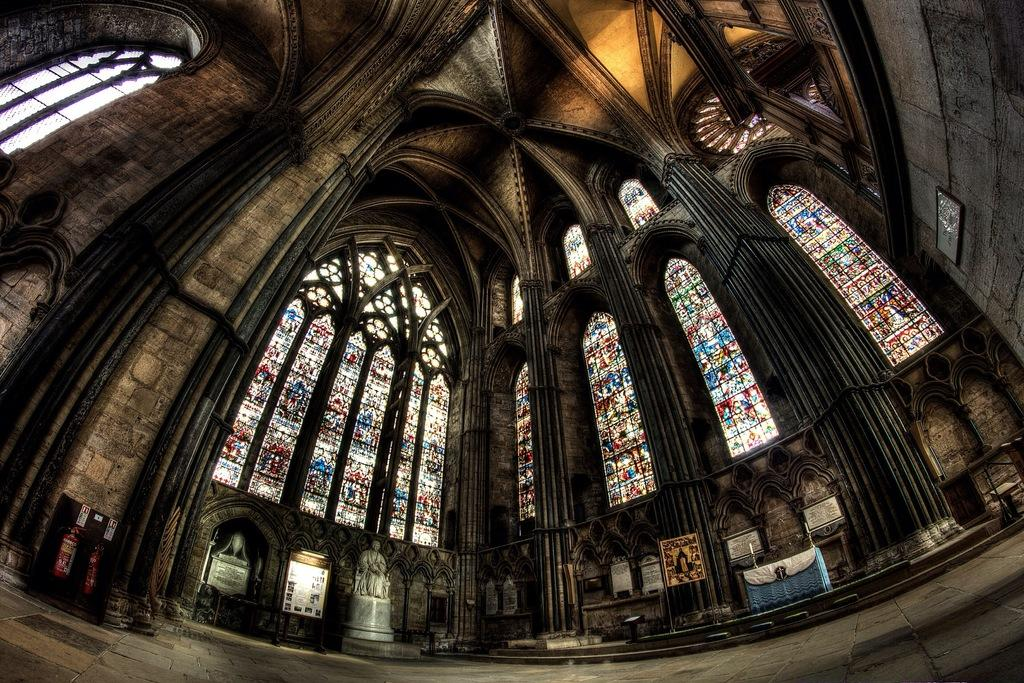What type of building is shown in the image? The image is an inside view of a church building. What feature can be seen in the church that allows natural light to enter? There are big glass windows in the church. What type of decorative elements are present in the church? There are statues in the church. What architectural feature supports the structure of the church? There are pillars in the church. What is the shape of the ceiling in the image? There is a dome at the top of the image. What safety equipment is present in the church? There are fire extinguishers in the church. What type of wall decorations can be seen in the church? There are photo frames in the church. What type of sugar is used to sweeten the oatmeal in the image? There is no sugar or oatmeal present in the image; it is an inside view of a church building. Can you describe the sidewalk outside the church in the image? There is no sidewalk visible in the image, as it is an inside view of the church. 